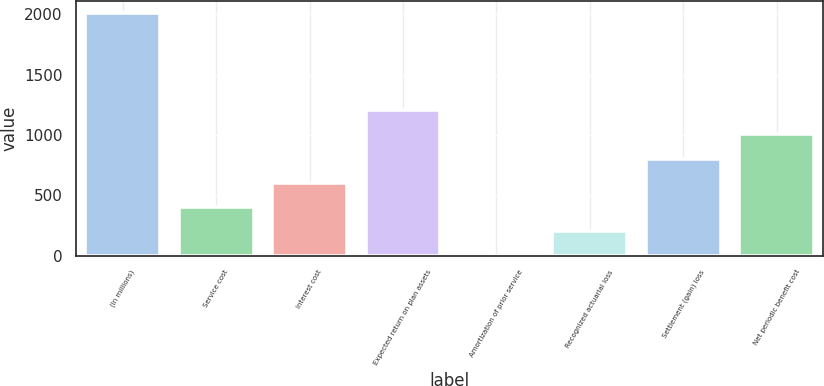Convert chart. <chart><loc_0><loc_0><loc_500><loc_500><bar_chart><fcel>(In millions)<fcel>Service cost<fcel>Interest cost<fcel>Expected return on plan assets<fcel>Amortization of prior service<fcel>Recognized actuarial loss<fcel>Settlement (gain) loss<fcel>Net periodic benefit cost<nl><fcel>2012<fcel>402.48<fcel>603.67<fcel>1207.24<fcel>0.1<fcel>201.29<fcel>804.86<fcel>1006.05<nl></chart> 